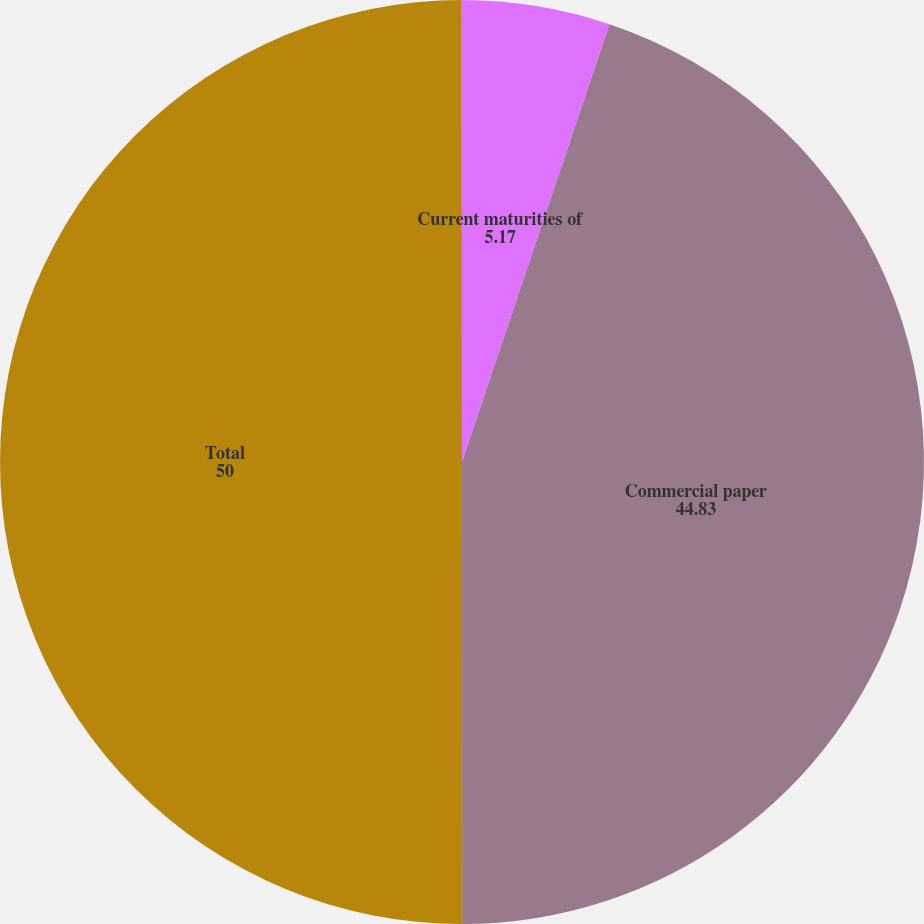Convert chart. <chart><loc_0><loc_0><loc_500><loc_500><pie_chart><fcel>Current maturities of<fcel>Commercial paper<fcel>Total<fcel>Interest rate for<nl><fcel>5.17%<fcel>44.83%<fcel>50.0%<fcel>0.01%<nl></chart> 